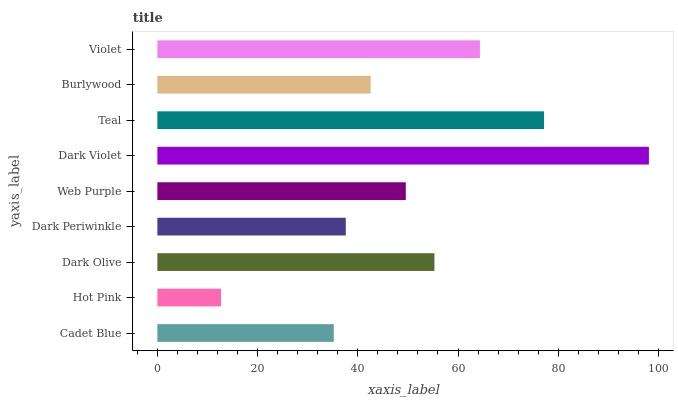Is Hot Pink the minimum?
Answer yes or no. Yes. Is Dark Violet the maximum?
Answer yes or no. Yes. Is Dark Olive the minimum?
Answer yes or no. No. Is Dark Olive the maximum?
Answer yes or no. No. Is Dark Olive greater than Hot Pink?
Answer yes or no. Yes. Is Hot Pink less than Dark Olive?
Answer yes or no. Yes. Is Hot Pink greater than Dark Olive?
Answer yes or no. No. Is Dark Olive less than Hot Pink?
Answer yes or no. No. Is Web Purple the high median?
Answer yes or no. Yes. Is Web Purple the low median?
Answer yes or no. Yes. Is Dark Periwinkle the high median?
Answer yes or no. No. Is Cadet Blue the low median?
Answer yes or no. No. 